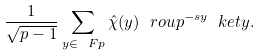<formula> <loc_0><loc_0><loc_500><loc_500>\frac { 1 } { \sqrt { p - 1 } } \sum _ { y \in \ F p } \hat { \chi } ( y ) \ r o u { p } ^ { - s y } \ k e t { y } .</formula> 